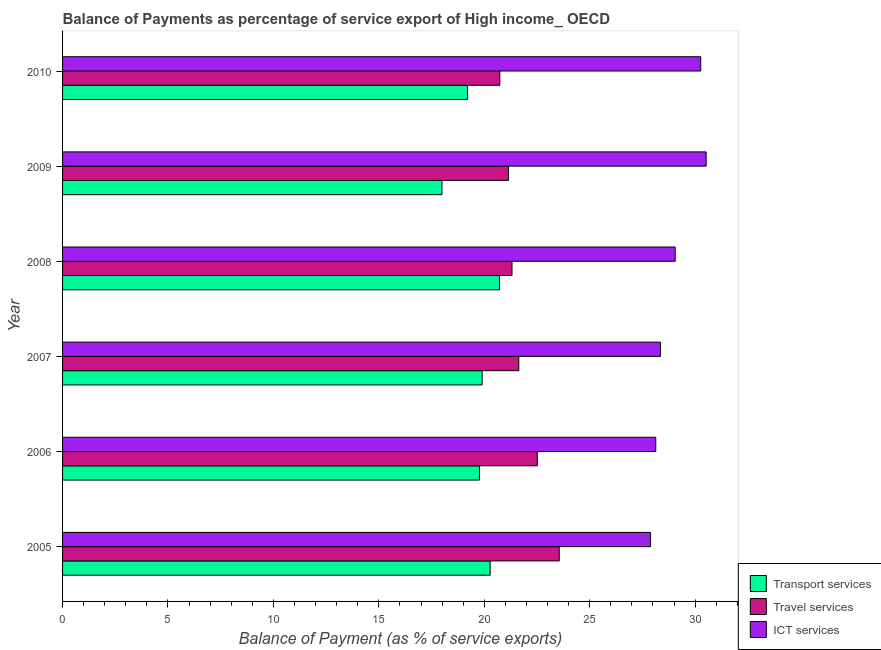Are the number of bars per tick equal to the number of legend labels?
Offer a terse response. Yes. Are the number of bars on each tick of the Y-axis equal?
Give a very brief answer. Yes. How many bars are there on the 1st tick from the top?
Offer a terse response. 3. What is the label of the 3rd group of bars from the top?
Offer a terse response. 2008. In how many cases, is the number of bars for a given year not equal to the number of legend labels?
Your answer should be very brief. 0. What is the balance of payment of ict services in 2006?
Ensure brevity in your answer.  28.13. Across all years, what is the maximum balance of payment of transport services?
Provide a short and direct response. 20.72. Across all years, what is the minimum balance of payment of ict services?
Your answer should be compact. 27.88. What is the total balance of payment of transport services in the graph?
Offer a terse response. 117.88. What is the difference between the balance of payment of ict services in 2006 and that in 2008?
Your response must be concise. -0.92. What is the difference between the balance of payment of ict services in 2009 and the balance of payment of transport services in 2008?
Make the answer very short. 9.8. What is the average balance of payment of ict services per year?
Provide a short and direct response. 29.04. In the year 2010, what is the difference between the balance of payment of ict services and balance of payment of travel services?
Ensure brevity in your answer.  9.53. In how many years, is the balance of payment of transport services greater than 22 %?
Your answer should be very brief. 0. What is the ratio of the balance of payment of transport services in 2005 to that in 2010?
Your answer should be very brief. 1.06. What is the difference between the highest and the second highest balance of payment of ict services?
Ensure brevity in your answer.  0.26. What is the difference between the highest and the lowest balance of payment of travel services?
Provide a short and direct response. 2.82. What does the 2nd bar from the top in 2010 represents?
Keep it short and to the point. Travel services. What does the 3rd bar from the bottom in 2005 represents?
Ensure brevity in your answer.  ICT services. Is it the case that in every year, the sum of the balance of payment of transport services and balance of payment of travel services is greater than the balance of payment of ict services?
Your answer should be compact. Yes. How many bars are there?
Give a very brief answer. 18. Are all the bars in the graph horizontal?
Keep it short and to the point. Yes. How many years are there in the graph?
Offer a very short reply. 6. What is the difference between two consecutive major ticks on the X-axis?
Make the answer very short. 5. Are the values on the major ticks of X-axis written in scientific E-notation?
Offer a terse response. No. Does the graph contain grids?
Offer a very short reply. No. Where does the legend appear in the graph?
Provide a succinct answer. Bottom right. How many legend labels are there?
Your answer should be very brief. 3. What is the title of the graph?
Offer a very short reply. Balance of Payments as percentage of service export of High income_ OECD. What is the label or title of the X-axis?
Your response must be concise. Balance of Payment (as % of service exports). What is the label or title of the Y-axis?
Your answer should be very brief. Year. What is the Balance of Payment (as % of service exports) in Transport services in 2005?
Offer a very short reply. 20.28. What is the Balance of Payment (as % of service exports) in Travel services in 2005?
Your response must be concise. 23.56. What is the Balance of Payment (as % of service exports) of ICT services in 2005?
Your answer should be very brief. 27.88. What is the Balance of Payment (as % of service exports) of Transport services in 2006?
Keep it short and to the point. 19.78. What is the Balance of Payment (as % of service exports) in Travel services in 2006?
Your answer should be compact. 22.52. What is the Balance of Payment (as % of service exports) of ICT services in 2006?
Your answer should be compact. 28.13. What is the Balance of Payment (as % of service exports) in Transport services in 2007?
Keep it short and to the point. 19.9. What is the Balance of Payment (as % of service exports) of Travel services in 2007?
Your answer should be compact. 21.64. What is the Balance of Payment (as % of service exports) in ICT services in 2007?
Ensure brevity in your answer.  28.35. What is the Balance of Payment (as % of service exports) of Transport services in 2008?
Ensure brevity in your answer.  20.72. What is the Balance of Payment (as % of service exports) in Travel services in 2008?
Provide a succinct answer. 21.32. What is the Balance of Payment (as % of service exports) of ICT services in 2008?
Keep it short and to the point. 29.06. What is the Balance of Payment (as % of service exports) of Transport services in 2009?
Make the answer very short. 17.99. What is the Balance of Payment (as % of service exports) of Travel services in 2009?
Make the answer very short. 21.15. What is the Balance of Payment (as % of service exports) in ICT services in 2009?
Offer a terse response. 30.52. What is the Balance of Payment (as % of service exports) of Transport services in 2010?
Your response must be concise. 19.21. What is the Balance of Payment (as % of service exports) of Travel services in 2010?
Offer a terse response. 20.74. What is the Balance of Payment (as % of service exports) in ICT services in 2010?
Your response must be concise. 30.27. Across all years, what is the maximum Balance of Payment (as % of service exports) of Transport services?
Offer a terse response. 20.72. Across all years, what is the maximum Balance of Payment (as % of service exports) of Travel services?
Ensure brevity in your answer.  23.56. Across all years, what is the maximum Balance of Payment (as % of service exports) in ICT services?
Give a very brief answer. 30.52. Across all years, what is the minimum Balance of Payment (as % of service exports) in Transport services?
Your answer should be very brief. 17.99. Across all years, what is the minimum Balance of Payment (as % of service exports) in Travel services?
Make the answer very short. 20.74. Across all years, what is the minimum Balance of Payment (as % of service exports) in ICT services?
Give a very brief answer. 27.88. What is the total Balance of Payment (as % of service exports) of Transport services in the graph?
Provide a short and direct response. 117.88. What is the total Balance of Payment (as % of service exports) of Travel services in the graph?
Keep it short and to the point. 130.92. What is the total Balance of Payment (as % of service exports) in ICT services in the graph?
Provide a short and direct response. 174.22. What is the difference between the Balance of Payment (as % of service exports) of Transport services in 2005 and that in 2006?
Offer a terse response. 0.5. What is the difference between the Balance of Payment (as % of service exports) in Travel services in 2005 and that in 2006?
Ensure brevity in your answer.  1.04. What is the difference between the Balance of Payment (as % of service exports) in ICT services in 2005 and that in 2006?
Make the answer very short. -0.25. What is the difference between the Balance of Payment (as % of service exports) of Transport services in 2005 and that in 2007?
Ensure brevity in your answer.  0.38. What is the difference between the Balance of Payment (as % of service exports) in Travel services in 2005 and that in 2007?
Offer a terse response. 1.92. What is the difference between the Balance of Payment (as % of service exports) in ICT services in 2005 and that in 2007?
Give a very brief answer. -0.47. What is the difference between the Balance of Payment (as % of service exports) of Transport services in 2005 and that in 2008?
Keep it short and to the point. -0.44. What is the difference between the Balance of Payment (as % of service exports) of Travel services in 2005 and that in 2008?
Your answer should be very brief. 2.24. What is the difference between the Balance of Payment (as % of service exports) in ICT services in 2005 and that in 2008?
Give a very brief answer. -1.17. What is the difference between the Balance of Payment (as % of service exports) in Transport services in 2005 and that in 2009?
Provide a succinct answer. 2.29. What is the difference between the Balance of Payment (as % of service exports) of Travel services in 2005 and that in 2009?
Your answer should be compact. 2.41. What is the difference between the Balance of Payment (as % of service exports) of ICT services in 2005 and that in 2009?
Provide a succinct answer. -2.64. What is the difference between the Balance of Payment (as % of service exports) in Transport services in 2005 and that in 2010?
Ensure brevity in your answer.  1.07. What is the difference between the Balance of Payment (as % of service exports) of Travel services in 2005 and that in 2010?
Your response must be concise. 2.82. What is the difference between the Balance of Payment (as % of service exports) of ICT services in 2005 and that in 2010?
Offer a terse response. -2.38. What is the difference between the Balance of Payment (as % of service exports) of Transport services in 2006 and that in 2007?
Provide a short and direct response. -0.12. What is the difference between the Balance of Payment (as % of service exports) of Travel services in 2006 and that in 2007?
Your answer should be compact. 0.88. What is the difference between the Balance of Payment (as % of service exports) in ICT services in 2006 and that in 2007?
Your response must be concise. -0.22. What is the difference between the Balance of Payment (as % of service exports) of Transport services in 2006 and that in 2008?
Provide a short and direct response. -0.95. What is the difference between the Balance of Payment (as % of service exports) in Travel services in 2006 and that in 2008?
Your answer should be compact. 1.2. What is the difference between the Balance of Payment (as % of service exports) of ICT services in 2006 and that in 2008?
Your answer should be very brief. -0.92. What is the difference between the Balance of Payment (as % of service exports) of Transport services in 2006 and that in 2009?
Give a very brief answer. 1.78. What is the difference between the Balance of Payment (as % of service exports) of Travel services in 2006 and that in 2009?
Your answer should be very brief. 1.37. What is the difference between the Balance of Payment (as % of service exports) in ICT services in 2006 and that in 2009?
Ensure brevity in your answer.  -2.39. What is the difference between the Balance of Payment (as % of service exports) of Transport services in 2006 and that in 2010?
Provide a short and direct response. 0.57. What is the difference between the Balance of Payment (as % of service exports) in Travel services in 2006 and that in 2010?
Give a very brief answer. 1.78. What is the difference between the Balance of Payment (as % of service exports) of ICT services in 2006 and that in 2010?
Keep it short and to the point. -2.13. What is the difference between the Balance of Payment (as % of service exports) of Transport services in 2007 and that in 2008?
Give a very brief answer. -0.82. What is the difference between the Balance of Payment (as % of service exports) in Travel services in 2007 and that in 2008?
Your response must be concise. 0.32. What is the difference between the Balance of Payment (as % of service exports) of ICT services in 2007 and that in 2008?
Your answer should be very brief. -0.7. What is the difference between the Balance of Payment (as % of service exports) in Transport services in 2007 and that in 2009?
Give a very brief answer. 1.91. What is the difference between the Balance of Payment (as % of service exports) of Travel services in 2007 and that in 2009?
Your answer should be very brief. 0.49. What is the difference between the Balance of Payment (as % of service exports) of ICT services in 2007 and that in 2009?
Provide a short and direct response. -2.17. What is the difference between the Balance of Payment (as % of service exports) of Transport services in 2007 and that in 2010?
Give a very brief answer. 0.69. What is the difference between the Balance of Payment (as % of service exports) of Travel services in 2007 and that in 2010?
Your answer should be very brief. 0.9. What is the difference between the Balance of Payment (as % of service exports) of ICT services in 2007 and that in 2010?
Provide a short and direct response. -1.91. What is the difference between the Balance of Payment (as % of service exports) of Transport services in 2008 and that in 2009?
Your response must be concise. 2.73. What is the difference between the Balance of Payment (as % of service exports) in Travel services in 2008 and that in 2009?
Keep it short and to the point. 0.17. What is the difference between the Balance of Payment (as % of service exports) of ICT services in 2008 and that in 2009?
Your answer should be very brief. -1.47. What is the difference between the Balance of Payment (as % of service exports) of Transport services in 2008 and that in 2010?
Your answer should be very brief. 1.51. What is the difference between the Balance of Payment (as % of service exports) of Travel services in 2008 and that in 2010?
Provide a succinct answer. 0.58. What is the difference between the Balance of Payment (as % of service exports) in ICT services in 2008 and that in 2010?
Give a very brief answer. -1.21. What is the difference between the Balance of Payment (as % of service exports) in Transport services in 2009 and that in 2010?
Your answer should be very brief. -1.22. What is the difference between the Balance of Payment (as % of service exports) of Travel services in 2009 and that in 2010?
Offer a terse response. 0.41. What is the difference between the Balance of Payment (as % of service exports) of ICT services in 2009 and that in 2010?
Give a very brief answer. 0.26. What is the difference between the Balance of Payment (as % of service exports) in Transport services in 2005 and the Balance of Payment (as % of service exports) in Travel services in 2006?
Offer a very short reply. -2.24. What is the difference between the Balance of Payment (as % of service exports) in Transport services in 2005 and the Balance of Payment (as % of service exports) in ICT services in 2006?
Your response must be concise. -7.86. What is the difference between the Balance of Payment (as % of service exports) in Travel services in 2005 and the Balance of Payment (as % of service exports) in ICT services in 2006?
Your answer should be compact. -4.58. What is the difference between the Balance of Payment (as % of service exports) in Transport services in 2005 and the Balance of Payment (as % of service exports) in Travel services in 2007?
Make the answer very short. -1.36. What is the difference between the Balance of Payment (as % of service exports) of Transport services in 2005 and the Balance of Payment (as % of service exports) of ICT services in 2007?
Offer a terse response. -8.07. What is the difference between the Balance of Payment (as % of service exports) in Travel services in 2005 and the Balance of Payment (as % of service exports) in ICT services in 2007?
Your answer should be compact. -4.8. What is the difference between the Balance of Payment (as % of service exports) in Transport services in 2005 and the Balance of Payment (as % of service exports) in Travel services in 2008?
Provide a short and direct response. -1.04. What is the difference between the Balance of Payment (as % of service exports) of Transport services in 2005 and the Balance of Payment (as % of service exports) of ICT services in 2008?
Make the answer very short. -8.78. What is the difference between the Balance of Payment (as % of service exports) of Travel services in 2005 and the Balance of Payment (as % of service exports) of ICT services in 2008?
Your response must be concise. -5.5. What is the difference between the Balance of Payment (as % of service exports) of Transport services in 2005 and the Balance of Payment (as % of service exports) of Travel services in 2009?
Ensure brevity in your answer.  -0.87. What is the difference between the Balance of Payment (as % of service exports) of Transport services in 2005 and the Balance of Payment (as % of service exports) of ICT services in 2009?
Keep it short and to the point. -10.24. What is the difference between the Balance of Payment (as % of service exports) in Travel services in 2005 and the Balance of Payment (as % of service exports) in ICT services in 2009?
Provide a succinct answer. -6.97. What is the difference between the Balance of Payment (as % of service exports) in Transport services in 2005 and the Balance of Payment (as % of service exports) in Travel services in 2010?
Ensure brevity in your answer.  -0.46. What is the difference between the Balance of Payment (as % of service exports) in Transport services in 2005 and the Balance of Payment (as % of service exports) in ICT services in 2010?
Offer a very short reply. -9.99. What is the difference between the Balance of Payment (as % of service exports) of Travel services in 2005 and the Balance of Payment (as % of service exports) of ICT services in 2010?
Offer a very short reply. -6.71. What is the difference between the Balance of Payment (as % of service exports) in Transport services in 2006 and the Balance of Payment (as % of service exports) in Travel services in 2007?
Offer a very short reply. -1.86. What is the difference between the Balance of Payment (as % of service exports) in Transport services in 2006 and the Balance of Payment (as % of service exports) in ICT services in 2007?
Your response must be concise. -8.58. What is the difference between the Balance of Payment (as % of service exports) of Travel services in 2006 and the Balance of Payment (as % of service exports) of ICT services in 2007?
Your response must be concise. -5.84. What is the difference between the Balance of Payment (as % of service exports) in Transport services in 2006 and the Balance of Payment (as % of service exports) in Travel services in 2008?
Offer a very short reply. -1.54. What is the difference between the Balance of Payment (as % of service exports) in Transport services in 2006 and the Balance of Payment (as % of service exports) in ICT services in 2008?
Ensure brevity in your answer.  -9.28. What is the difference between the Balance of Payment (as % of service exports) of Travel services in 2006 and the Balance of Payment (as % of service exports) of ICT services in 2008?
Ensure brevity in your answer.  -6.54. What is the difference between the Balance of Payment (as % of service exports) of Transport services in 2006 and the Balance of Payment (as % of service exports) of Travel services in 2009?
Your answer should be compact. -1.37. What is the difference between the Balance of Payment (as % of service exports) of Transport services in 2006 and the Balance of Payment (as % of service exports) of ICT services in 2009?
Keep it short and to the point. -10.75. What is the difference between the Balance of Payment (as % of service exports) of Travel services in 2006 and the Balance of Payment (as % of service exports) of ICT services in 2009?
Give a very brief answer. -8.01. What is the difference between the Balance of Payment (as % of service exports) in Transport services in 2006 and the Balance of Payment (as % of service exports) in Travel services in 2010?
Ensure brevity in your answer.  -0.96. What is the difference between the Balance of Payment (as % of service exports) in Transport services in 2006 and the Balance of Payment (as % of service exports) in ICT services in 2010?
Keep it short and to the point. -10.49. What is the difference between the Balance of Payment (as % of service exports) of Travel services in 2006 and the Balance of Payment (as % of service exports) of ICT services in 2010?
Keep it short and to the point. -7.75. What is the difference between the Balance of Payment (as % of service exports) of Transport services in 2007 and the Balance of Payment (as % of service exports) of Travel services in 2008?
Make the answer very short. -1.42. What is the difference between the Balance of Payment (as % of service exports) in Transport services in 2007 and the Balance of Payment (as % of service exports) in ICT services in 2008?
Your response must be concise. -9.16. What is the difference between the Balance of Payment (as % of service exports) of Travel services in 2007 and the Balance of Payment (as % of service exports) of ICT services in 2008?
Ensure brevity in your answer.  -7.42. What is the difference between the Balance of Payment (as % of service exports) of Transport services in 2007 and the Balance of Payment (as % of service exports) of Travel services in 2009?
Offer a very short reply. -1.25. What is the difference between the Balance of Payment (as % of service exports) in Transport services in 2007 and the Balance of Payment (as % of service exports) in ICT services in 2009?
Offer a terse response. -10.62. What is the difference between the Balance of Payment (as % of service exports) in Travel services in 2007 and the Balance of Payment (as % of service exports) in ICT services in 2009?
Ensure brevity in your answer.  -8.89. What is the difference between the Balance of Payment (as % of service exports) in Transport services in 2007 and the Balance of Payment (as % of service exports) in Travel services in 2010?
Provide a short and direct response. -0.84. What is the difference between the Balance of Payment (as % of service exports) in Transport services in 2007 and the Balance of Payment (as % of service exports) in ICT services in 2010?
Your answer should be very brief. -10.37. What is the difference between the Balance of Payment (as % of service exports) of Travel services in 2007 and the Balance of Payment (as % of service exports) of ICT services in 2010?
Give a very brief answer. -8.63. What is the difference between the Balance of Payment (as % of service exports) of Transport services in 2008 and the Balance of Payment (as % of service exports) of Travel services in 2009?
Your answer should be compact. -0.43. What is the difference between the Balance of Payment (as % of service exports) of Transport services in 2008 and the Balance of Payment (as % of service exports) of ICT services in 2009?
Offer a very short reply. -9.8. What is the difference between the Balance of Payment (as % of service exports) of Travel services in 2008 and the Balance of Payment (as % of service exports) of ICT services in 2009?
Make the answer very short. -9.21. What is the difference between the Balance of Payment (as % of service exports) in Transport services in 2008 and the Balance of Payment (as % of service exports) in Travel services in 2010?
Make the answer very short. -0.02. What is the difference between the Balance of Payment (as % of service exports) in Transport services in 2008 and the Balance of Payment (as % of service exports) in ICT services in 2010?
Your answer should be very brief. -9.55. What is the difference between the Balance of Payment (as % of service exports) of Travel services in 2008 and the Balance of Payment (as % of service exports) of ICT services in 2010?
Make the answer very short. -8.95. What is the difference between the Balance of Payment (as % of service exports) of Transport services in 2009 and the Balance of Payment (as % of service exports) of Travel services in 2010?
Offer a very short reply. -2.75. What is the difference between the Balance of Payment (as % of service exports) in Transport services in 2009 and the Balance of Payment (as % of service exports) in ICT services in 2010?
Your answer should be very brief. -12.27. What is the difference between the Balance of Payment (as % of service exports) in Travel services in 2009 and the Balance of Payment (as % of service exports) in ICT services in 2010?
Offer a very short reply. -9.12. What is the average Balance of Payment (as % of service exports) in Transport services per year?
Ensure brevity in your answer.  19.65. What is the average Balance of Payment (as % of service exports) of Travel services per year?
Provide a succinct answer. 21.82. What is the average Balance of Payment (as % of service exports) in ICT services per year?
Keep it short and to the point. 29.04. In the year 2005, what is the difference between the Balance of Payment (as % of service exports) of Transport services and Balance of Payment (as % of service exports) of Travel services?
Offer a very short reply. -3.28. In the year 2005, what is the difference between the Balance of Payment (as % of service exports) in Transport services and Balance of Payment (as % of service exports) in ICT services?
Keep it short and to the point. -7.6. In the year 2005, what is the difference between the Balance of Payment (as % of service exports) in Travel services and Balance of Payment (as % of service exports) in ICT services?
Make the answer very short. -4.33. In the year 2006, what is the difference between the Balance of Payment (as % of service exports) of Transport services and Balance of Payment (as % of service exports) of Travel services?
Offer a terse response. -2.74. In the year 2006, what is the difference between the Balance of Payment (as % of service exports) in Transport services and Balance of Payment (as % of service exports) in ICT services?
Give a very brief answer. -8.36. In the year 2006, what is the difference between the Balance of Payment (as % of service exports) of Travel services and Balance of Payment (as % of service exports) of ICT services?
Give a very brief answer. -5.62. In the year 2007, what is the difference between the Balance of Payment (as % of service exports) of Transport services and Balance of Payment (as % of service exports) of Travel services?
Provide a succinct answer. -1.74. In the year 2007, what is the difference between the Balance of Payment (as % of service exports) of Transport services and Balance of Payment (as % of service exports) of ICT services?
Your response must be concise. -8.45. In the year 2007, what is the difference between the Balance of Payment (as % of service exports) in Travel services and Balance of Payment (as % of service exports) in ICT services?
Offer a terse response. -6.72. In the year 2008, what is the difference between the Balance of Payment (as % of service exports) of Transport services and Balance of Payment (as % of service exports) of Travel services?
Your response must be concise. -0.6. In the year 2008, what is the difference between the Balance of Payment (as % of service exports) in Transport services and Balance of Payment (as % of service exports) in ICT services?
Provide a succinct answer. -8.33. In the year 2008, what is the difference between the Balance of Payment (as % of service exports) in Travel services and Balance of Payment (as % of service exports) in ICT services?
Offer a very short reply. -7.74. In the year 2009, what is the difference between the Balance of Payment (as % of service exports) of Transport services and Balance of Payment (as % of service exports) of Travel services?
Offer a very short reply. -3.16. In the year 2009, what is the difference between the Balance of Payment (as % of service exports) in Transport services and Balance of Payment (as % of service exports) in ICT services?
Your answer should be very brief. -12.53. In the year 2009, what is the difference between the Balance of Payment (as % of service exports) of Travel services and Balance of Payment (as % of service exports) of ICT services?
Make the answer very short. -9.37. In the year 2010, what is the difference between the Balance of Payment (as % of service exports) of Transport services and Balance of Payment (as % of service exports) of Travel services?
Offer a very short reply. -1.53. In the year 2010, what is the difference between the Balance of Payment (as % of service exports) of Transport services and Balance of Payment (as % of service exports) of ICT services?
Your answer should be compact. -11.06. In the year 2010, what is the difference between the Balance of Payment (as % of service exports) of Travel services and Balance of Payment (as % of service exports) of ICT services?
Provide a short and direct response. -9.53. What is the ratio of the Balance of Payment (as % of service exports) in Transport services in 2005 to that in 2006?
Give a very brief answer. 1.03. What is the ratio of the Balance of Payment (as % of service exports) of Travel services in 2005 to that in 2006?
Give a very brief answer. 1.05. What is the ratio of the Balance of Payment (as % of service exports) in ICT services in 2005 to that in 2006?
Offer a very short reply. 0.99. What is the ratio of the Balance of Payment (as % of service exports) in Transport services in 2005 to that in 2007?
Make the answer very short. 1.02. What is the ratio of the Balance of Payment (as % of service exports) in Travel services in 2005 to that in 2007?
Offer a terse response. 1.09. What is the ratio of the Balance of Payment (as % of service exports) of ICT services in 2005 to that in 2007?
Offer a terse response. 0.98. What is the ratio of the Balance of Payment (as % of service exports) of Transport services in 2005 to that in 2008?
Provide a short and direct response. 0.98. What is the ratio of the Balance of Payment (as % of service exports) in Travel services in 2005 to that in 2008?
Offer a very short reply. 1.11. What is the ratio of the Balance of Payment (as % of service exports) of ICT services in 2005 to that in 2008?
Offer a terse response. 0.96. What is the ratio of the Balance of Payment (as % of service exports) of Transport services in 2005 to that in 2009?
Provide a succinct answer. 1.13. What is the ratio of the Balance of Payment (as % of service exports) of Travel services in 2005 to that in 2009?
Offer a very short reply. 1.11. What is the ratio of the Balance of Payment (as % of service exports) in ICT services in 2005 to that in 2009?
Give a very brief answer. 0.91. What is the ratio of the Balance of Payment (as % of service exports) of Transport services in 2005 to that in 2010?
Your response must be concise. 1.06. What is the ratio of the Balance of Payment (as % of service exports) of Travel services in 2005 to that in 2010?
Your response must be concise. 1.14. What is the ratio of the Balance of Payment (as % of service exports) in ICT services in 2005 to that in 2010?
Offer a terse response. 0.92. What is the ratio of the Balance of Payment (as % of service exports) of Transport services in 2006 to that in 2007?
Make the answer very short. 0.99. What is the ratio of the Balance of Payment (as % of service exports) in Travel services in 2006 to that in 2007?
Provide a succinct answer. 1.04. What is the ratio of the Balance of Payment (as % of service exports) in Transport services in 2006 to that in 2008?
Provide a short and direct response. 0.95. What is the ratio of the Balance of Payment (as % of service exports) of Travel services in 2006 to that in 2008?
Your answer should be very brief. 1.06. What is the ratio of the Balance of Payment (as % of service exports) of ICT services in 2006 to that in 2008?
Give a very brief answer. 0.97. What is the ratio of the Balance of Payment (as % of service exports) in Transport services in 2006 to that in 2009?
Your answer should be very brief. 1.1. What is the ratio of the Balance of Payment (as % of service exports) of Travel services in 2006 to that in 2009?
Your answer should be compact. 1.06. What is the ratio of the Balance of Payment (as % of service exports) in ICT services in 2006 to that in 2009?
Provide a succinct answer. 0.92. What is the ratio of the Balance of Payment (as % of service exports) of Transport services in 2006 to that in 2010?
Offer a very short reply. 1.03. What is the ratio of the Balance of Payment (as % of service exports) in Travel services in 2006 to that in 2010?
Give a very brief answer. 1.09. What is the ratio of the Balance of Payment (as % of service exports) of ICT services in 2006 to that in 2010?
Your answer should be very brief. 0.93. What is the ratio of the Balance of Payment (as % of service exports) of Transport services in 2007 to that in 2008?
Ensure brevity in your answer.  0.96. What is the ratio of the Balance of Payment (as % of service exports) of Travel services in 2007 to that in 2008?
Offer a very short reply. 1.02. What is the ratio of the Balance of Payment (as % of service exports) of ICT services in 2007 to that in 2008?
Give a very brief answer. 0.98. What is the ratio of the Balance of Payment (as % of service exports) in Transport services in 2007 to that in 2009?
Your answer should be very brief. 1.11. What is the ratio of the Balance of Payment (as % of service exports) in Travel services in 2007 to that in 2009?
Provide a short and direct response. 1.02. What is the ratio of the Balance of Payment (as % of service exports) in ICT services in 2007 to that in 2009?
Your response must be concise. 0.93. What is the ratio of the Balance of Payment (as % of service exports) of Transport services in 2007 to that in 2010?
Ensure brevity in your answer.  1.04. What is the ratio of the Balance of Payment (as % of service exports) in Travel services in 2007 to that in 2010?
Provide a short and direct response. 1.04. What is the ratio of the Balance of Payment (as % of service exports) in ICT services in 2007 to that in 2010?
Offer a very short reply. 0.94. What is the ratio of the Balance of Payment (as % of service exports) of Transport services in 2008 to that in 2009?
Provide a short and direct response. 1.15. What is the ratio of the Balance of Payment (as % of service exports) in Travel services in 2008 to that in 2009?
Offer a terse response. 1.01. What is the ratio of the Balance of Payment (as % of service exports) of ICT services in 2008 to that in 2009?
Your answer should be very brief. 0.95. What is the ratio of the Balance of Payment (as % of service exports) in Transport services in 2008 to that in 2010?
Give a very brief answer. 1.08. What is the ratio of the Balance of Payment (as % of service exports) of Travel services in 2008 to that in 2010?
Your response must be concise. 1.03. What is the ratio of the Balance of Payment (as % of service exports) of ICT services in 2008 to that in 2010?
Ensure brevity in your answer.  0.96. What is the ratio of the Balance of Payment (as % of service exports) of Transport services in 2009 to that in 2010?
Ensure brevity in your answer.  0.94. What is the ratio of the Balance of Payment (as % of service exports) of Travel services in 2009 to that in 2010?
Offer a very short reply. 1.02. What is the ratio of the Balance of Payment (as % of service exports) of ICT services in 2009 to that in 2010?
Offer a terse response. 1.01. What is the difference between the highest and the second highest Balance of Payment (as % of service exports) in Transport services?
Provide a short and direct response. 0.44. What is the difference between the highest and the second highest Balance of Payment (as % of service exports) in Travel services?
Give a very brief answer. 1.04. What is the difference between the highest and the second highest Balance of Payment (as % of service exports) of ICT services?
Give a very brief answer. 0.26. What is the difference between the highest and the lowest Balance of Payment (as % of service exports) of Transport services?
Ensure brevity in your answer.  2.73. What is the difference between the highest and the lowest Balance of Payment (as % of service exports) of Travel services?
Your response must be concise. 2.82. What is the difference between the highest and the lowest Balance of Payment (as % of service exports) of ICT services?
Offer a very short reply. 2.64. 